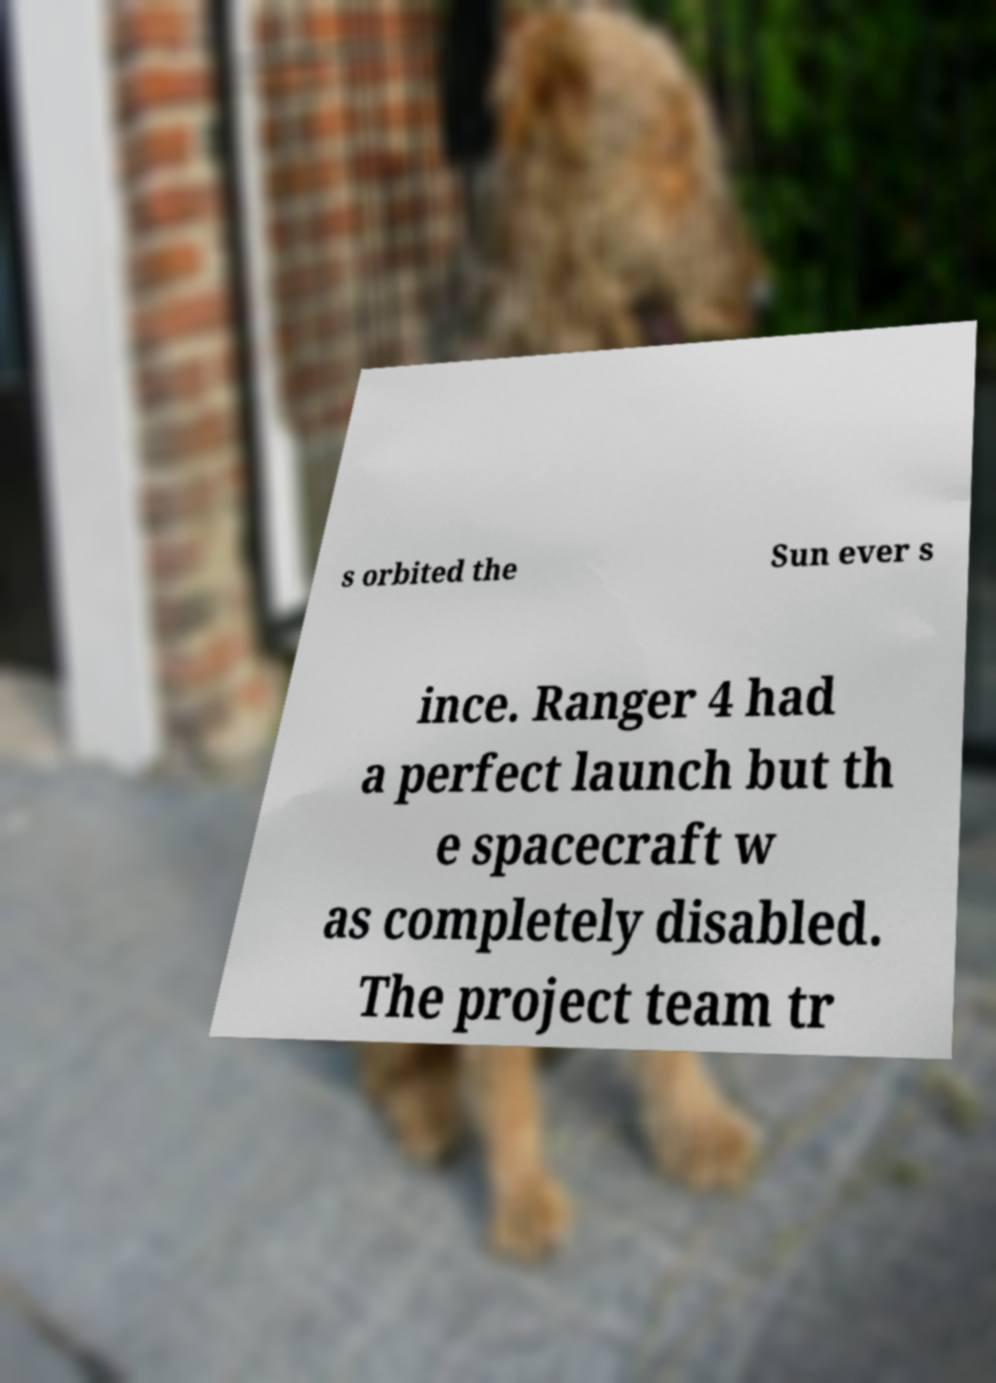I need the written content from this picture converted into text. Can you do that? s orbited the Sun ever s ince. Ranger 4 had a perfect launch but th e spacecraft w as completely disabled. The project team tr 